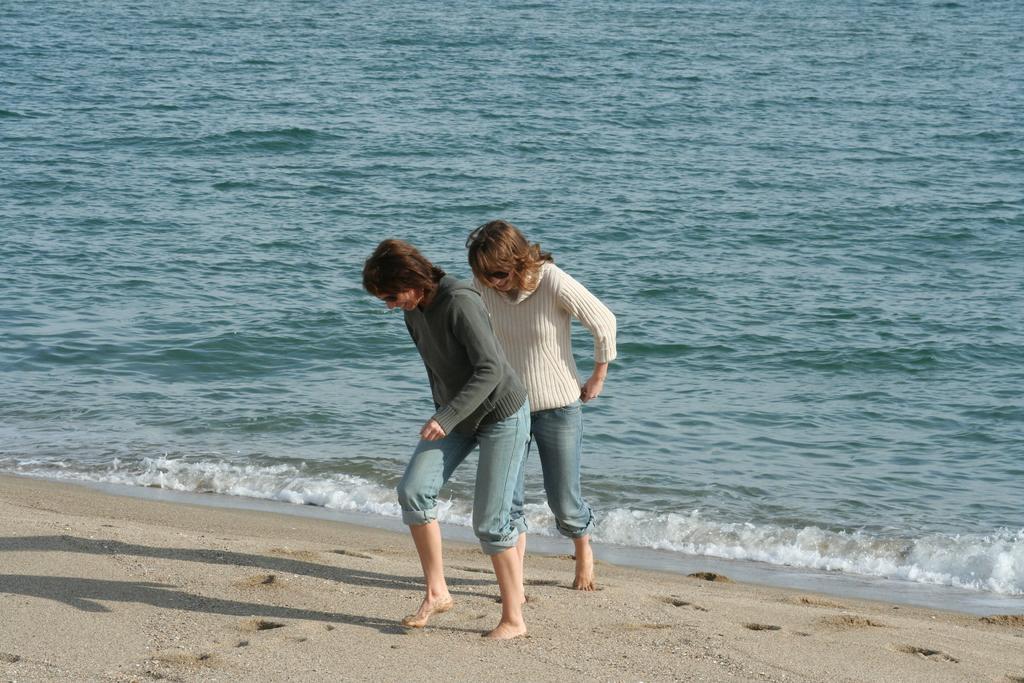Can you describe this image briefly? In the middle I can see two persons on the beach. In the background I can see water. This image is taken on the sandy beach during a day. 